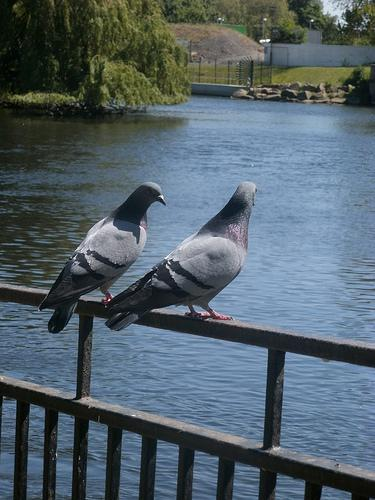State the total number of pigeons and their relative positions in the image. There are two pigeons; one is to the left of the other. Please provide a brief sentiment analysis of the image with respect to the atmosphere. The image has a serene and peaceful atmosphere due to the calm water, green trees, and pigeons calmly resting on the railing. In a concise statement, describe the relations between the different objects near the lake. There is a white wall, a metal railing, and a small grassy hill next to the lake, with a pile of rocks and green trees also nearby. Explain the interaction between the pigeons and their immediate surroundings. The pigeons are interacting with their surroundings by standing on a metal railing that is near a calm lake. Assuming this picture was taken in a park, answer this complex reasoning question: what human activity can be done around this calm lake? A possible human activity that can be done around this calm lake in a park is recreational fishing or bird-watching. What kind of environment can be seen around the pigeons? The environment around the pigeons includes a lake, trees, rocks, a white building, and a grassy hill. What is the predominant color of the pigeons in the image? The pigeons in the image are predominantly gray. Identify the two main components of the scene involving the pigeons. The two main components are the pigeons sitting on a metal railing and the railing itself. How many main objects are there in the image, and what are they? There are six main objects: two pigeons, a metal railing, a lake, a grassy hill, and a white building. List the key elements in the image that contribute to the overall quality. The key elements contributing to the image quality are the pigeons, metal railing, calm water, green trees, and white building. Is the white wall made of bricks? There is a mention of a white wall but nothing specifically describing it as being made of bricks. Is there a large boat floating on the calm water? No, it's not mentioned in the image. How can you describe the appearance of the pigeon's eye? The pigeon has a beady black eye. Is the pigeon sitting on the grassy hill? There is no mention of any pigeon sitting on a grassy hill, only pigeons sitting on metal railings are mentioned. What's the color of the vertical bar near the water? black Specify the location of the white wall near the lake. The white wall is behind the small green grassy hill situated next to the lake. What's the color of the pile of rocks near the lake? light gray Describe the position of the green hill near the lake. The small green grassy hill is situated next to the lake and in front of the white wall. What kind of trees are found in the scene? Large green trees Which object can be seen behind the large rock pile? A grassy hill is visible behind the large rock pile. What kind of metal is the railing made of? The railing is made of black metal. List all the colors found on the pigeon. The pigeon has gray, red, black, and dark gray colors. Explain the position of the metal fence in the image. The metal fence is located near the lake and positioned next to the small green grassy hill and the short white wall. What unique feature does the pigeon's beak have? The pigeon has a pointy beak. How many pigeons are there in total on the railing? Two pigeons Identify the color of the foot of the pigeon sitting on the railing. red Describe the scene captured in the image. The image shows two pigeons sitting on a black metal railing near a calm blue lake surrounded by green trees, a white building, a grassy hill and a pile of large gray rocks. A short white wall and a metal fence can also be seen near the lake. What is the color of the tail feather found on one of the pigeons? dark gray Is the building near the lake red in color? There is a mention of a white building but not a red building next to the lake. Are the pigeons sitting on a wooden railing? The pigeons are mentioned to be sitting on a metal railing, not a wooden one. State the color of the building next to the lake. white How can you describe the water in the image? The water is calm and blue. Identify and describe the position of the largest object in the scene. The largest object is the black metal railing on which the pigeons are sitting, and it is situated next to the blue lake. Which objects can be found to the left of the pigeon sitting on the railing? There's another pigeon, green trees, and a calm blue lake to the left of the pigeon sitting on the railing. 